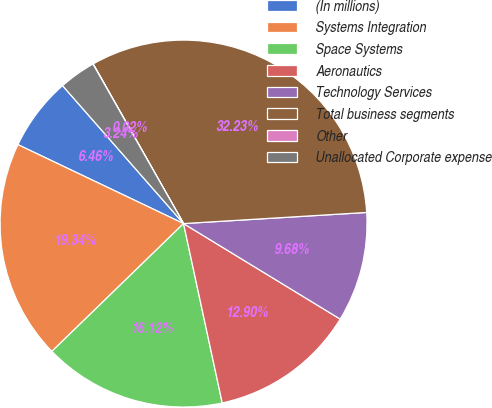Convert chart to OTSL. <chart><loc_0><loc_0><loc_500><loc_500><pie_chart><fcel>(In millions)<fcel>Systems Integration<fcel>Space Systems<fcel>Aeronautics<fcel>Technology Services<fcel>Total business segments<fcel>Other<fcel>Unallocated Corporate expense<nl><fcel>6.46%<fcel>19.34%<fcel>16.12%<fcel>12.9%<fcel>9.68%<fcel>32.23%<fcel>0.02%<fcel>3.24%<nl></chart> 